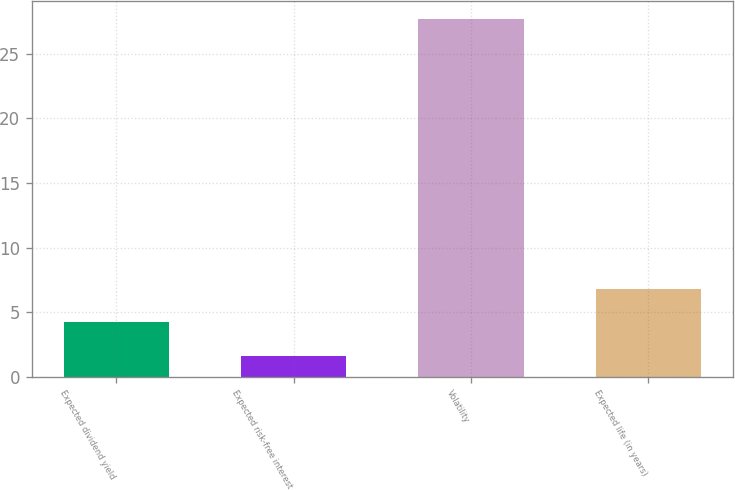Convert chart. <chart><loc_0><loc_0><loc_500><loc_500><bar_chart><fcel>Expected dividend yield<fcel>Expected risk-free interest<fcel>Volatility<fcel>Expected life (in years)<nl><fcel>4.21<fcel>1.6<fcel>27.7<fcel>6.82<nl></chart> 